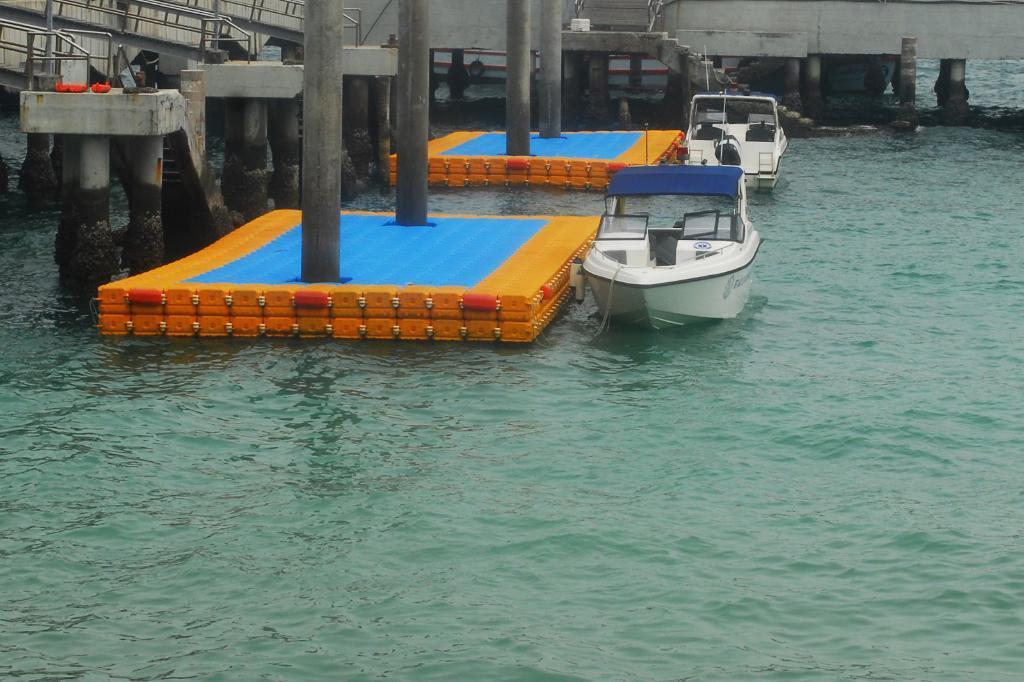Could you give a brief overview of what you see in this image? There are two white boats on water and there is a surface which are yellow and blue in color beside it and there is a staircase in the background. 